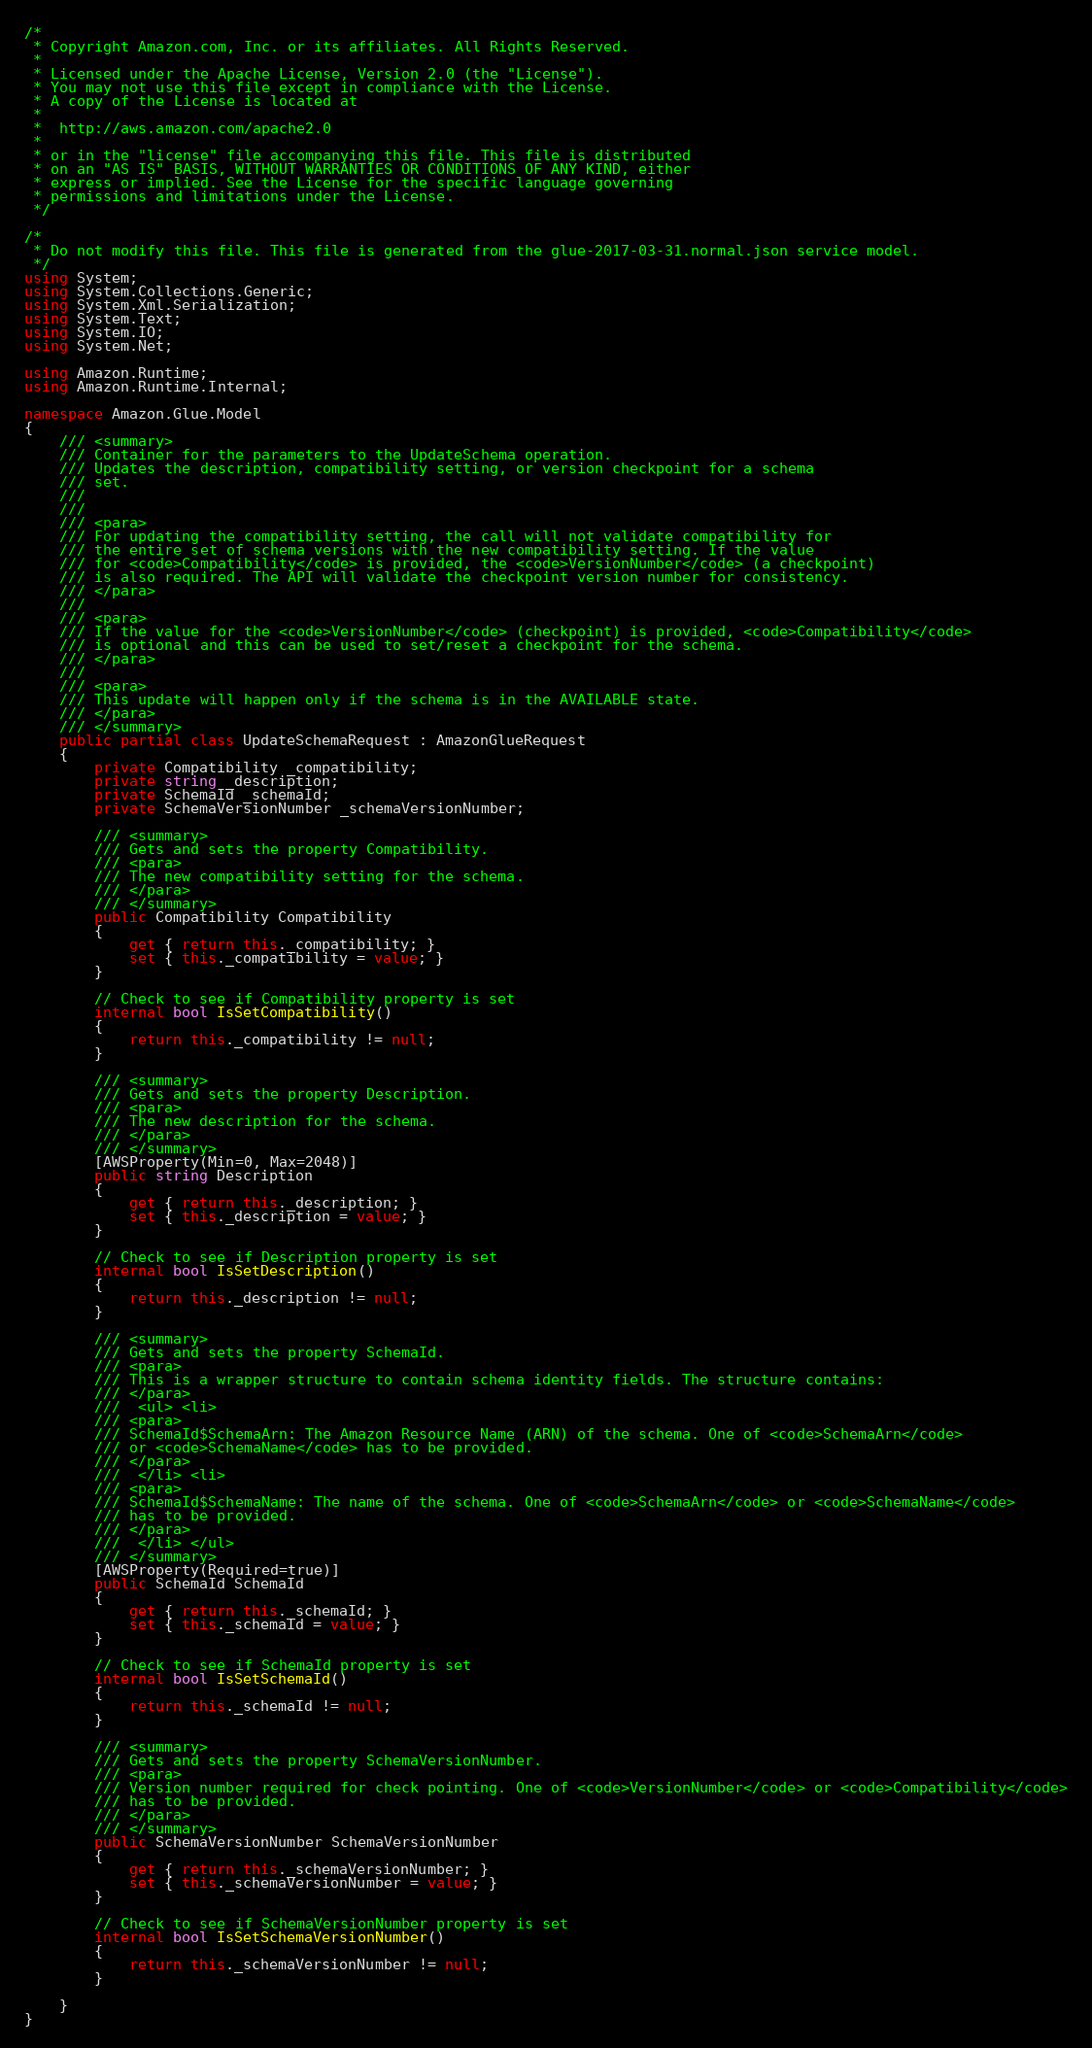Convert code to text. <code><loc_0><loc_0><loc_500><loc_500><_C#_>/*
 * Copyright Amazon.com, Inc. or its affiliates. All Rights Reserved.
 * 
 * Licensed under the Apache License, Version 2.0 (the "License").
 * You may not use this file except in compliance with the License.
 * A copy of the License is located at
 * 
 *  http://aws.amazon.com/apache2.0
 * 
 * or in the "license" file accompanying this file. This file is distributed
 * on an "AS IS" BASIS, WITHOUT WARRANTIES OR CONDITIONS OF ANY KIND, either
 * express or implied. See the License for the specific language governing
 * permissions and limitations under the License.
 */

/*
 * Do not modify this file. This file is generated from the glue-2017-03-31.normal.json service model.
 */
using System;
using System.Collections.Generic;
using System.Xml.Serialization;
using System.Text;
using System.IO;
using System.Net;

using Amazon.Runtime;
using Amazon.Runtime.Internal;

namespace Amazon.Glue.Model
{
    /// <summary>
    /// Container for the parameters to the UpdateSchema operation.
    /// Updates the description, compatibility setting, or version checkpoint for a schema
    /// set.
    /// 
    ///  
    /// <para>
    /// For updating the compatibility setting, the call will not validate compatibility for
    /// the entire set of schema versions with the new compatibility setting. If the value
    /// for <code>Compatibility</code> is provided, the <code>VersionNumber</code> (a checkpoint)
    /// is also required. The API will validate the checkpoint version number for consistency.
    /// </para>
    ///  
    /// <para>
    /// If the value for the <code>VersionNumber</code> (checkpoint) is provided, <code>Compatibility</code>
    /// is optional and this can be used to set/reset a checkpoint for the schema.
    /// </para>
    ///  
    /// <para>
    /// This update will happen only if the schema is in the AVAILABLE state.
    /// </para>
    /// </summary>
    public partial class UpdateSchemaRequest : AmazonGlueRequest
    {
        private Compatibility _compatibility;
        private string _description;
        private SchemaId _schemaId;
        private SchemaVersionNumber _schemaVersionNumber;

        /// <summary>
        /// Gets and sets the property Compatibility. 
        /// <para>
        /// The new compatibility setting for the schema.
        /// </para>
        /// </summary>
        public Compatibility Compatibility
        {
            get { return this._compatibility; }
            set { this._compatibility = value; }
        }

        // Check to see if Compatibility property is set
        internal bool IsSetCompatibility()
        {
            return this._compatibility != null;
        }

        /// <summary>
        /// Gets and sets the property Description. 
        /// <para>
        /// The new description for the schema.
        /// </para>
        /// </summary>
        [AWSProperty(Min=0, Max=2048)]
        public string Description
        {
            get { return this._description; }
            set { this._description = value; }
        }

        // Check to see if Description property is set
        internal bool IsSetDescription()
        {
            return this._description != null;
        }

        /// <summary>
        /// Gets and sets the property SchemaId. 
        /// <para>
        /// This is a wrapper structure to contain schema identity fields. The structure contains:
        /// </para>
        ///  <ul> <li> 
        /// <para>
        /// SchemaId$SchemaArn: The Amazon Resource Name (ARN) of the schema. One of <code>SchemaArn</code>
        /// or <code>SchemaName</code> has to be provided.
        /// </para>
        ///  </li> <li> 
        /// <para>
        /// SchemaId$SchemaName: The name of the schema. One of <code>SchemaArn</code> or <code>SchemaName</code>
        /// has to be provided.
        /// </para>
        ///  </li> </ul>
        /// </summary>
        [AWSProperty(Required=true)]
        public SchemaId SchemaId
        {
            get { return this._schemaId; }
            set { this._schemaId = value; }
        }

        // Check to see if SchemaId property is set
        internal bool IsSetSchemaId()
        {
            return this._schemaId != null;
        }

        /// <summary>
        /// Gets and sets the property SchemaVersionNumber. 
        /// <para>
        /// Version number required for check pointing. One of <code>VersionNumber</code> or <code>Compatibility</code>
        /// has to be provided.
        /// </para>
        /// </summary>
        public SchemaVersionNumber SchemaVersionNumber
        {
            get { return this._schemaVersionNumber; }
            set { this._schemaVersionNumber = value; }
        }

        // Check to see if SchemaVersionNumber property is set
        internal bool IsSetSchemaVersionNumber()
        {
            return this._schemaVersionNumber != null;
        }

    }
}</code> 